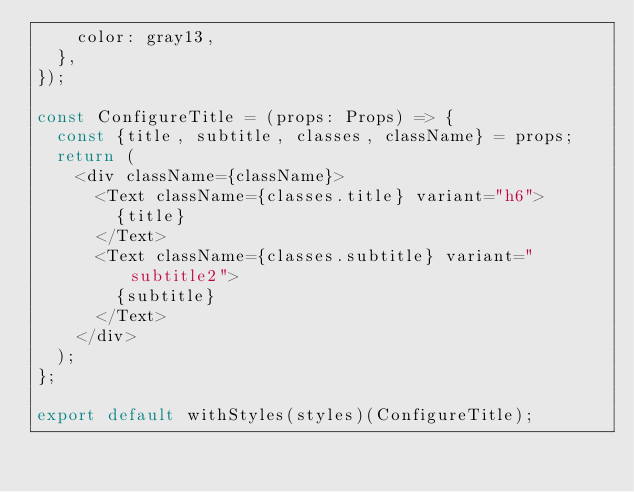Convert code to text. <code><loc_0><loc_0><loc_500><loc_500><_JavaScript_>    color: gray13,
  },
});

const ConfigureTitle = (props: Props) => {
  const {title, subtitle, classes, className} = props;
  return (
    <div className={className}>
      <Text className={classes.title} variant="h6">
        {title}
      </Text>
      <Text className={classes.subtitle} variant="subtitle2">
        {subtitle}
      </Text>
    </div>
  );
};

export default withStyles(styles)(ConfigureTitle);
</code> 